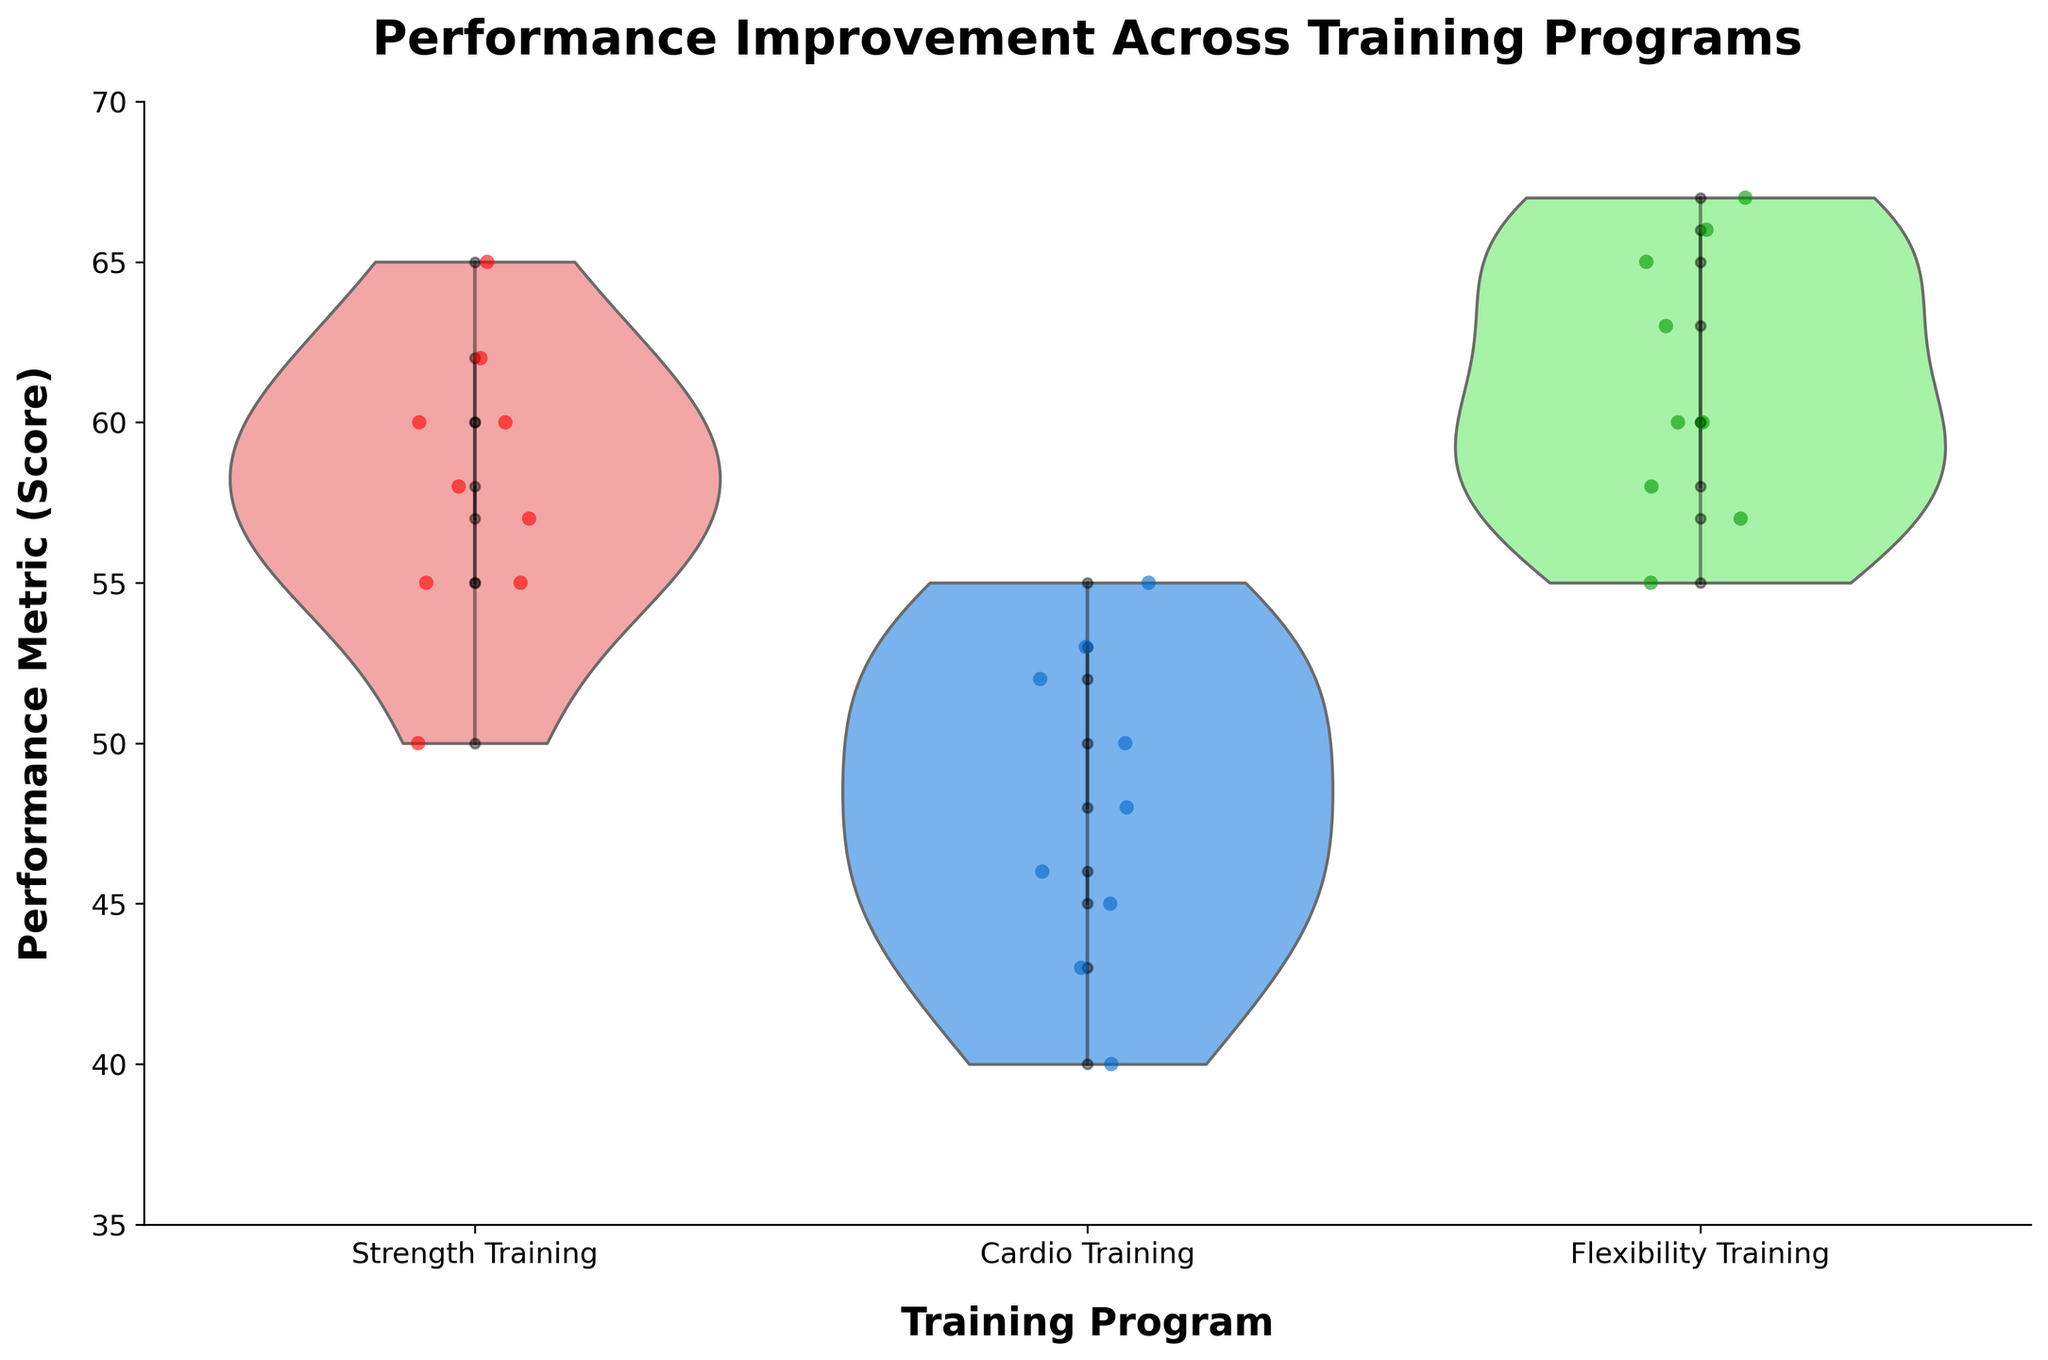What is the title of the figure? The title is usually located at the top of the figure and it provides a brief description of what the figure is displaying.
Answer: Performance Improvement Across Training Programs How many different training programs are shown in the figure? The distinct categories on the x-axis represent different training programs. By counting these categories, we can determine how many training programs are displayed.
Answer: 3 Which training program shows the highest range in performance scores? By observing the vertical spread (height) of the violin plots, we can determine which training program has the widest range of performance scores.
Answer: Flexibility Training What color represents the ‘Cardio Training’ program in the violin plots? By looking at the color of the violin plot labeled as 'Cardio Training' on the x-axis, we can identify the color used for this program.
Answer: Blue Are there any visible trends in performance improvement for trainees in the ‘Strength Training’ program? By observing the jittered points connected by black lines, we can see if there is a consistent upward or downward trend over the sessions for ‘Strength Training’.
Answer: Yes, there is a visible trend of improvement What is the lowest performance score recorded in the ‘Cardio Training’ program? By looking at the bottom edge of the violin plot and jittered points for 'Cardio Training', we can identify the lowest score recorded.
Answer: 40 Which trainee has the most consistent performance in 'Flexibility Training'? By observing the black lines in the 'Flexibility Training' section that connect jittered points for each trainee, we can identify which line is the most horizontal/least variable.
Answer: Alice Compare the median performance score in ‘Strength Training’ and 'Cardio Training'. Which one is higher? By observing the thickness and central tendency of the violin plots, we can determine the approximate median values for both training programs and compare them.
Answer: Strength Training How do the performance trends for ‘Charlie’ in the 'Cardio Training' program compare to those in the 'Strength Training' program? By tracing the black lines connecting Charlie's points in both training programs, we can compare the slopes and directions of the trends.
Answer: Both show improvement, but 'Strength Training' has a steeper improvement Is the variability in performance scores higher in ‘Strength Training’ or ‘Flexibility Training’? By comparing the width of the violin plots for 'Strength Training' and 'Flexibility Training', we can assess which has greater variability.
Answer: Flexibility Training 